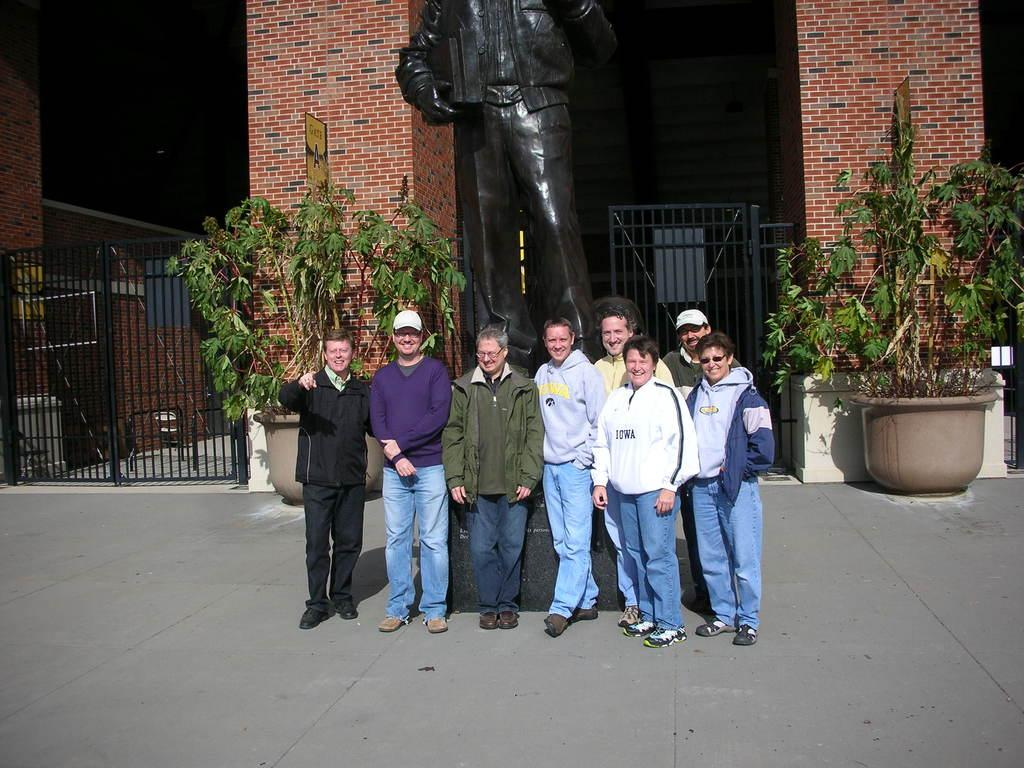What is the main subject of the image? The main subject of the image is a group of persons standing in the middle of the image. What can be seen in the background of the image? There are trees in the background of the image. What is located at the top of the image? There is a statue visible at the top of the image. What type of structure is present in the image? There is a building in the image. What type of quiver is being used by the persons in the image? There is no quiver present in the image; the persons are not holding any such objects. Can you tell me how the magic is being performed by the persons in the image? There is no magic being performed by the persons in the image; they are simply standing together. 